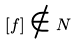<formula> <loc_0><loc_0><loc_500><loc_500>[ f ] \notin N</formula> 